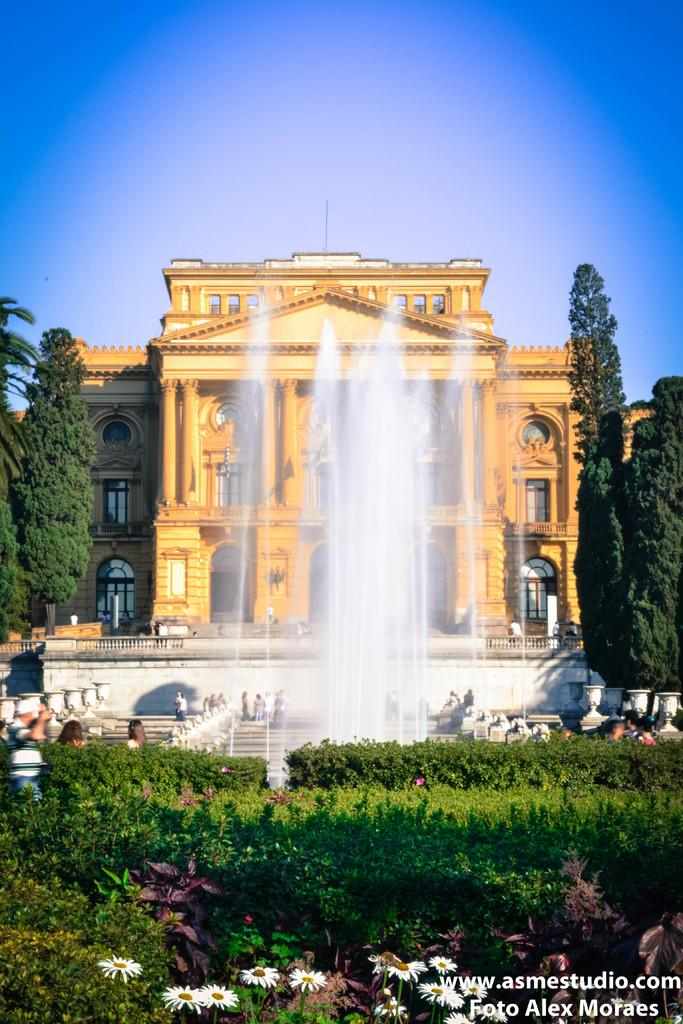What type of structure is in the image? There is a building in the image. What is the color of the building? The building is in a golden color. What is located in front of the building? There is a fountain in front of the building. What type of vegetation is at the bottom of the image? There are plants at the bottom of the image. What can be seen on either side of the building? There are big trees to the left and right of the building. How does the building wash its clothes in the image? The building does not wash clothes in the image; it is a structure and not capable of performing such actions. 